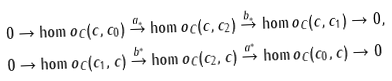<formula> <loc_0><loc_0><loc_500><loc_500>& 0 \to \hom o _ { C } ( c , c _ { 0 } ) \stackrel { a _ { * } } { \to } \hom o _ { C } ( c , c _ { 2 } ) \stackrel { b _ { * } } { \to } \hom o _ { C } ( c , c _ { 1 } ) \to 0 , \\ & 0 \to \hom o _ { C } ( c _ { 1 } , c ) \stackrel { b ^ { * } } { \to } \hom o _ { C } ( c _ { 2 } , c ) \stackrel { a ^ { * } } { \to } \hom o _ { C } ( c _ { 0 } , c ) \to 0</formula> 